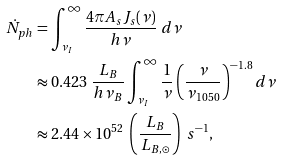<formula> <loc_0><loc_0><loc_500><loc_500>\dot { N } _ { p h } & = \int _ { \nu _ { I } } ^ { \infty } \frac { 4 \pi A _ { s } J _ { s } ( \nu ) } { h \nu } \ d \nu \\ & \approx 0 . 4 2 3 \ \frac { L _ { B } } { h \nu _ { B } } \int _ { \nu _ { I } } ^ { \infty } \frac { 1 } { \nu } \left ( \frac { \nu } { \nu _ { 1 0 5 0 } } \right ) ^ { - 1 . 8 } d \nu \\ & \approx 2 . 4 4 \times 1 0 ^ { 5 2 } \ \left ( \frac { L _ { B } } { L _ { B , \odot } } \right ) \ s ^ { - 1 } ,</formula> 